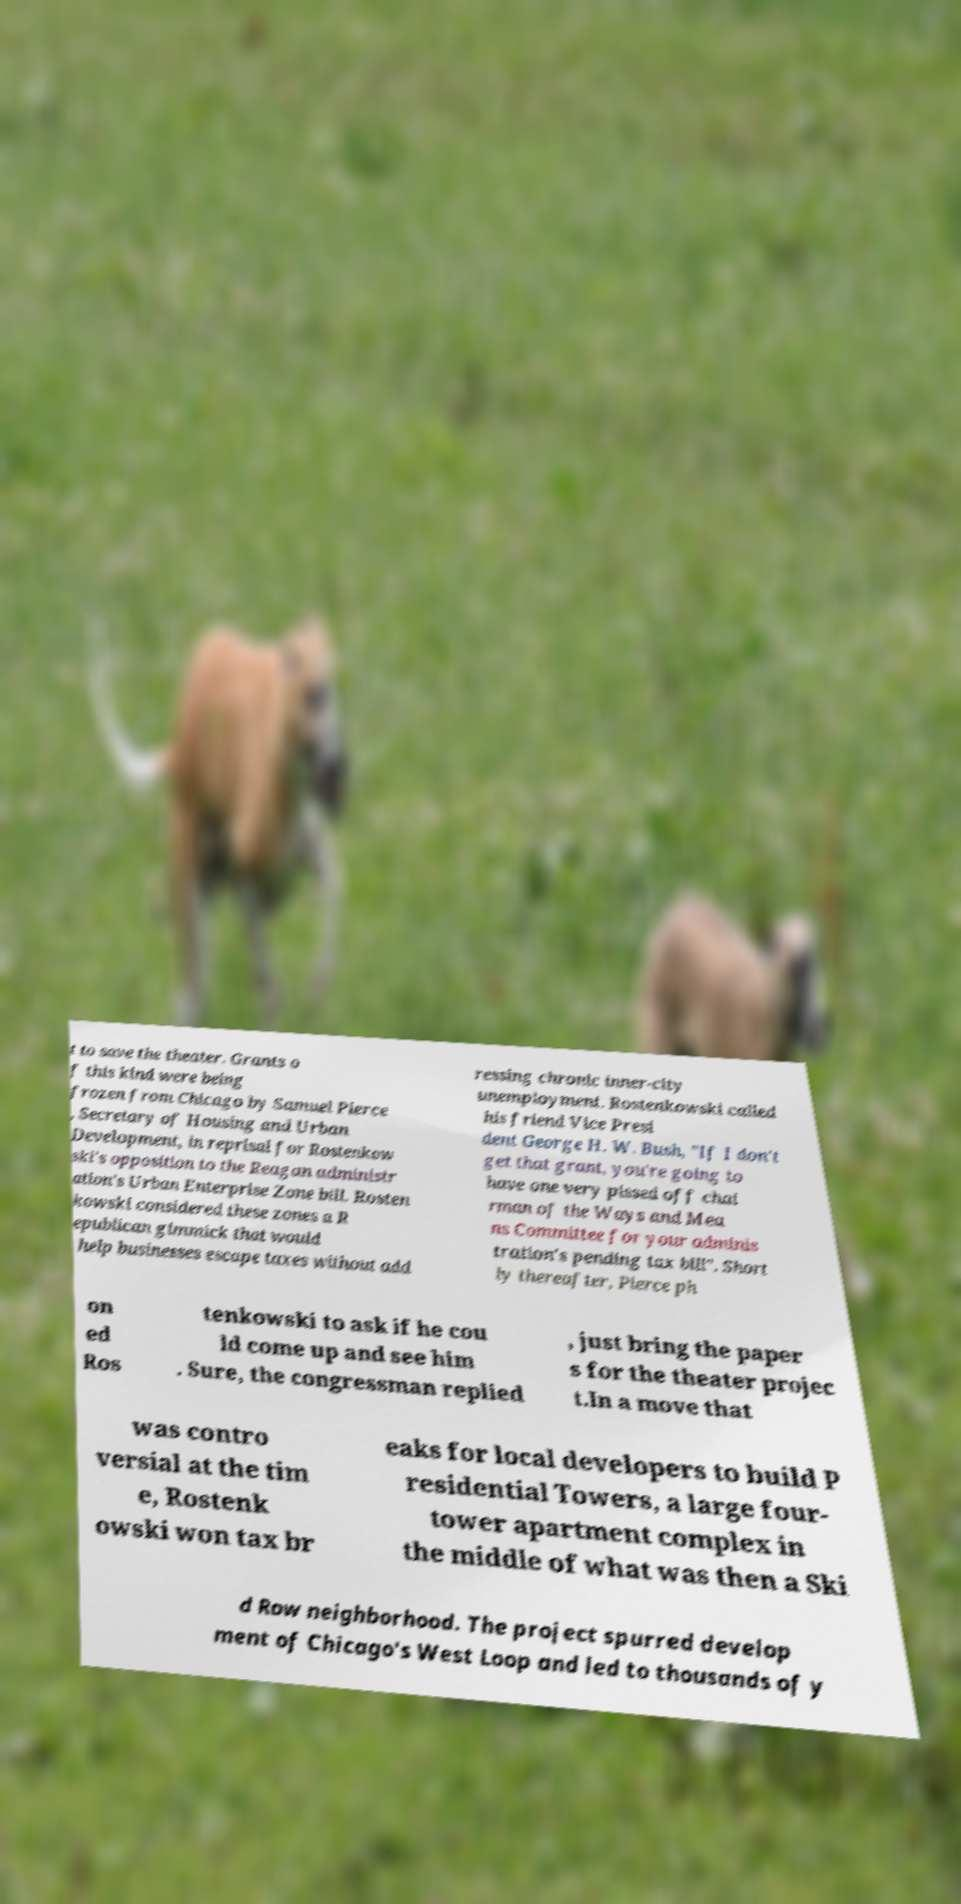Could you extract and type out the text from this image? t to save the theater. Grants o f this kind were being frozen from Chicago by Samuel Pierce , Secretary of Housing and Urban Development, in reprisal for Rostenkow ski's opposition to the Reagan administr ation's Urban Enterprise Zone bill. Rosten kowski considered these zones a R epublican gimmick that would help businesses escape taxes without add ressing chronic inner-city unemployment. Rostenkowski called his friend Vice Presi dent George H. W. Bush, "If I don't get that grant, you're going to have one very pissed off chai rman of the Ways and Mea ns Committee for your adminis tration's pending tax bill". Short ly thereafter, Pierce ph on ed Ros tenkowski to ask if he cou ld come up and see him . Sure, the congressman replied , just bring the paper s for the theater projec t.In a move that was contro versial at the tim e, Rostenk owski won tax br eaks for local developers to build P residential Towers, a large four- tower apartment complex in the middle of what was then a Ski d Row neighborhood. The project spurred develop ment of Chicago's West Loop and led to thousands of y 